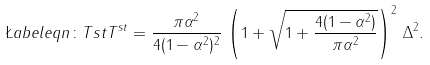<formula> <loc_0><loc_0><loc_500><loc_500>\L a b e l { e q n \colon T s t } T ^ { s t } = \frac { \pi \alpha ^ { 2 } } { 4 ( 1 - \alpha ^ { 2 } ) ^ { 2 } } \, \left ( 1 + \sqrt { 1 + \frac { 4 ( 1 - \alpha ^ { 2 } ) } { \pi \alpha ^ { 2 } } } \right ) ^ { 2 } \, \Delta ^ { 2 } .</formula> 